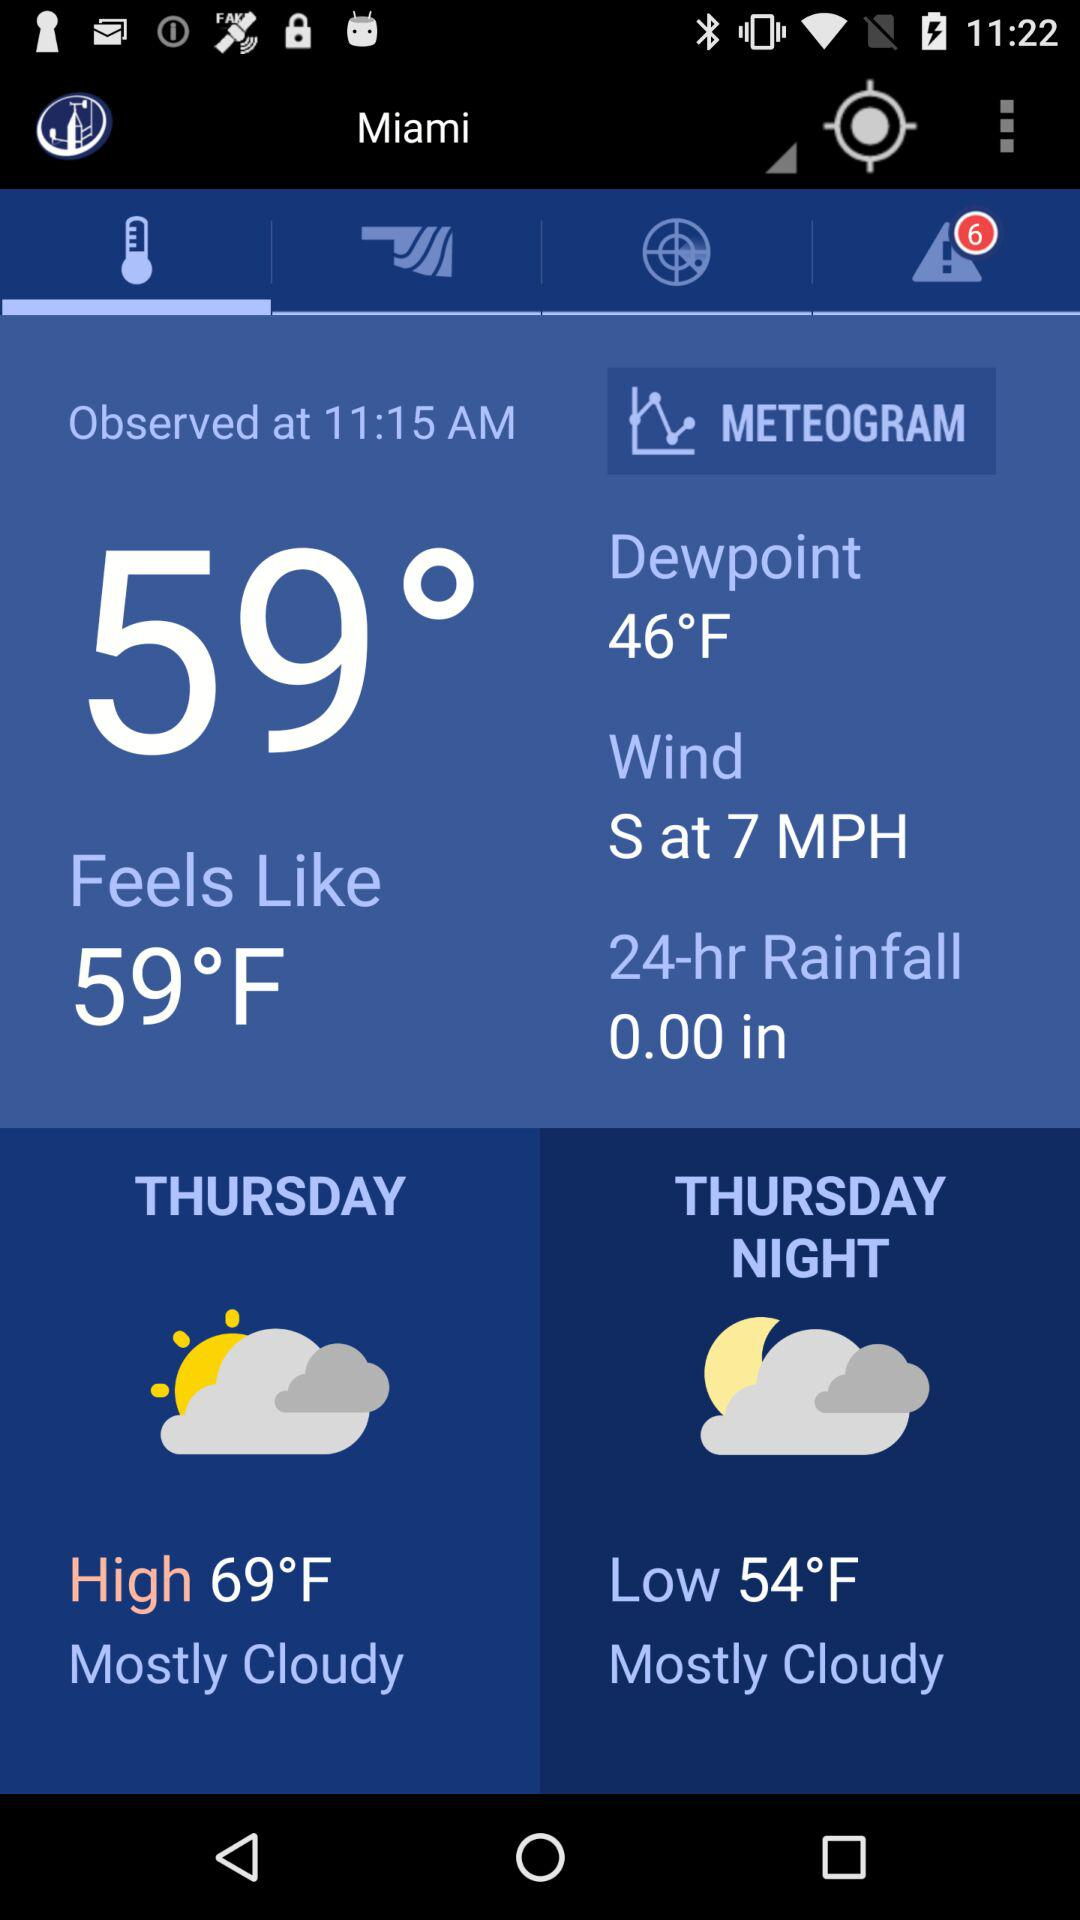What is the wind direction? The wind direction is "S at 7 MPH". 